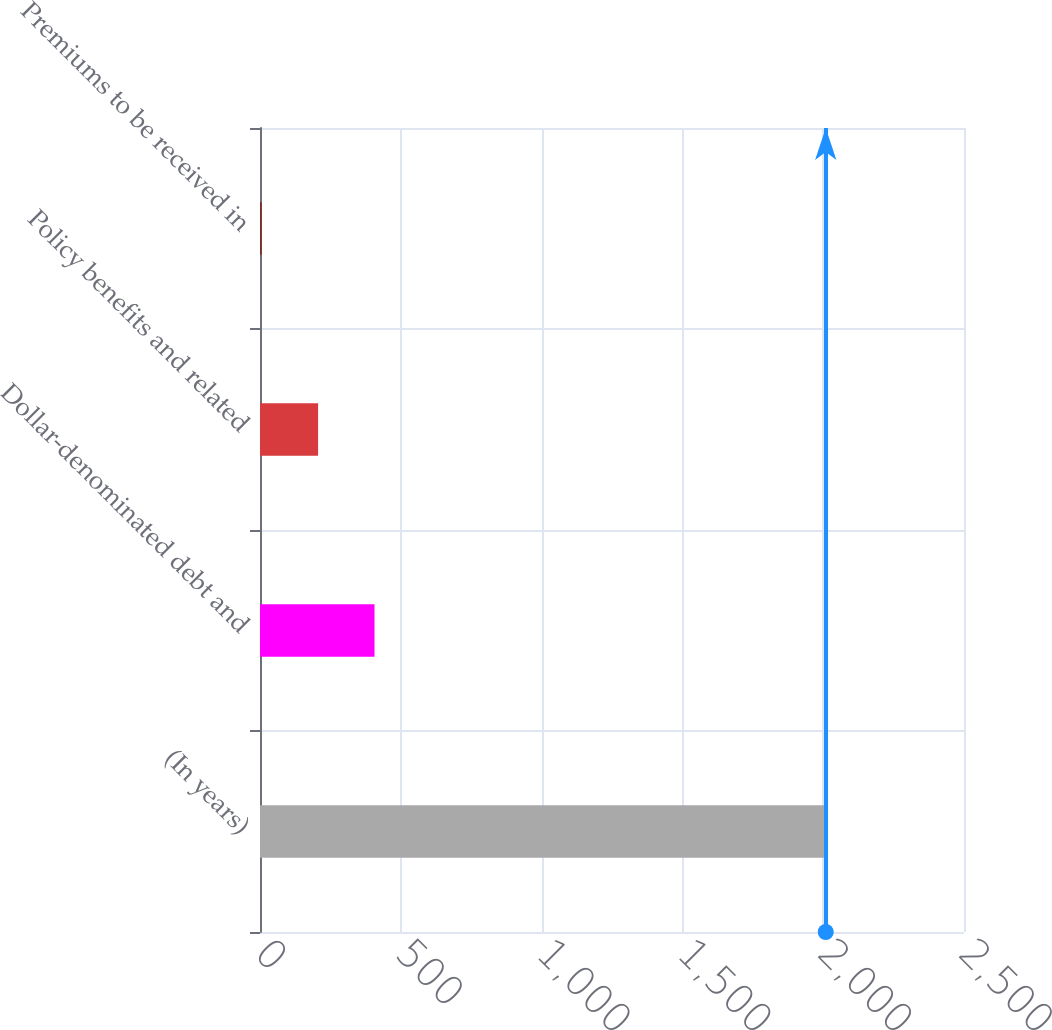Convert chart. <chart><loc_0><loc_0><loc_500><loc_500><bar_chart><fcel>(In years)<fcel>Dollar-denominated debt and<fcel>Policy benefits and related<fcel>Premiums to be received in<nl><fcel>2009<fcel>406.6<fcel>206.3<fcel>6<nl></chart> 